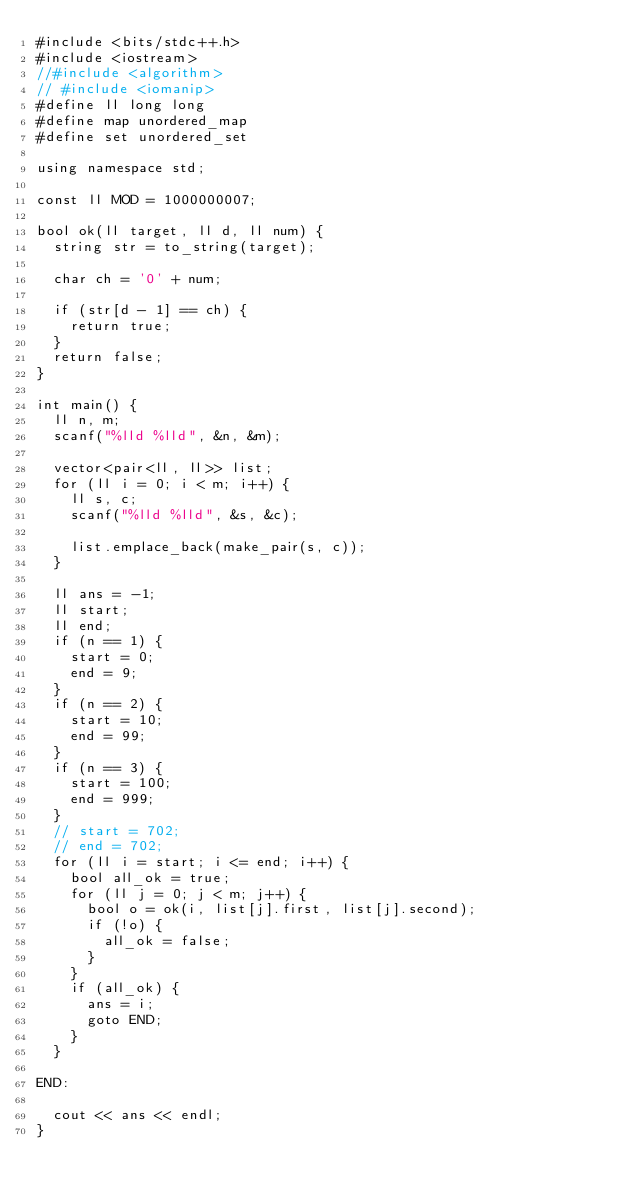Convert code to text. <code><loc_0><loc_0><loc_500><loc_500><_C++_>#include <bits/stdc++.h>
#include <iostream>
//#include <algorithm>
// #include <iomanip>
#define ll long long
#define map unordered_map
#define set unordered_set

using namespace std;

const ll MOD = 1000000007;

bool ok(ll target, ll d, ll num) {
  string str = to_string(target);

  char ch = '0' + num;

  if (str[d - 1] == ch) {
    return true;
  }
  return false;
}

int main() {
  ll n, m;
  scanf("%lld %lld", &n, &m);

  vector<pair<ll, ll>> list;
  for (ll i = 0; i < m; i++) {
    ll s, c;
    scanf("%lld %lld", &s, &c);

    list.emplace_back(make_pair(s, c));
  }

  ll ans = -1;
  ll start;
  ll end;
  if (n == 1) {
    start = 0;
    end = 9;
  }
  if (n == 2) {
    start = 10;
    end = 99;
  }
  if (n == 3) {
    start = 100;
    end = 999;
  }
  // start = 702;
  // end = 702;
  for (ll i = start; i <= end; i++) {
    bool all_ok = true;
    for (ll j = 0; j < m; j++) {
      bool o = ok(i, list[j].first, list[j].second);
      if (!o) {
        all_ok = false;
      }
    }
    if (all_ok) {
      ans = i;
      goto END;
    }
  }

END:

  cout << ans << endl;
}
</code> 